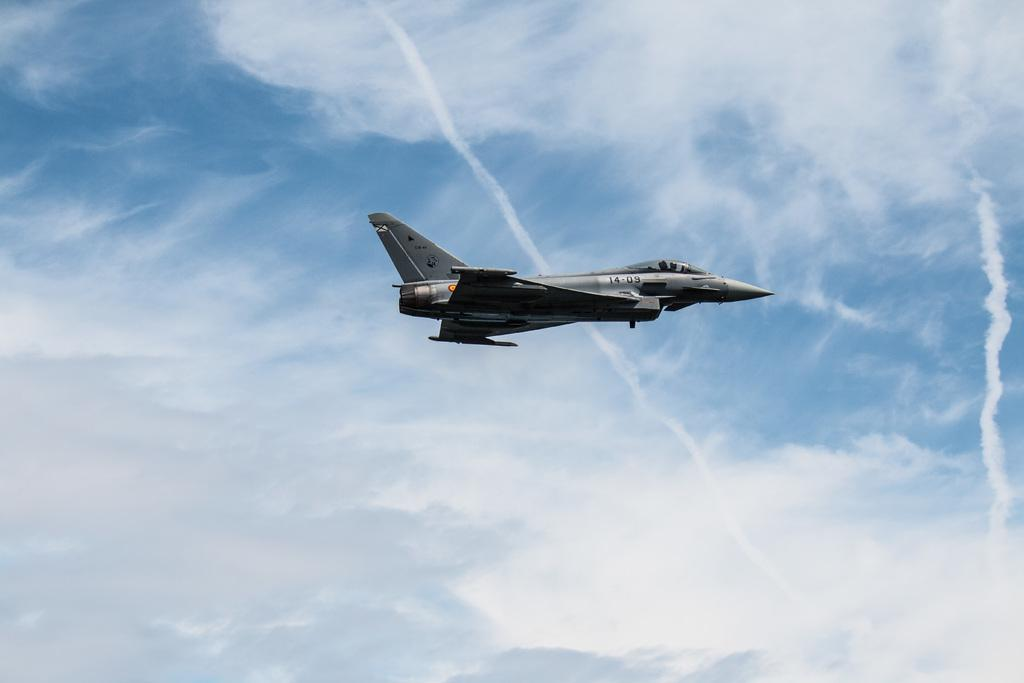What is the main subject of the image? The main subject of the image is an aircraft. What is the aircraft doing in the image? The aircraft is flying in the sky. How does the aircraft help people with their credit in the image? There is no indication in the image that the aircraft is helping people with their credit. The image only shows an aircraft flying in the sky. 